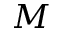Convert formula to latex. <formula><loc_0><loc_0><loc_500><loc_500>M</formula> 